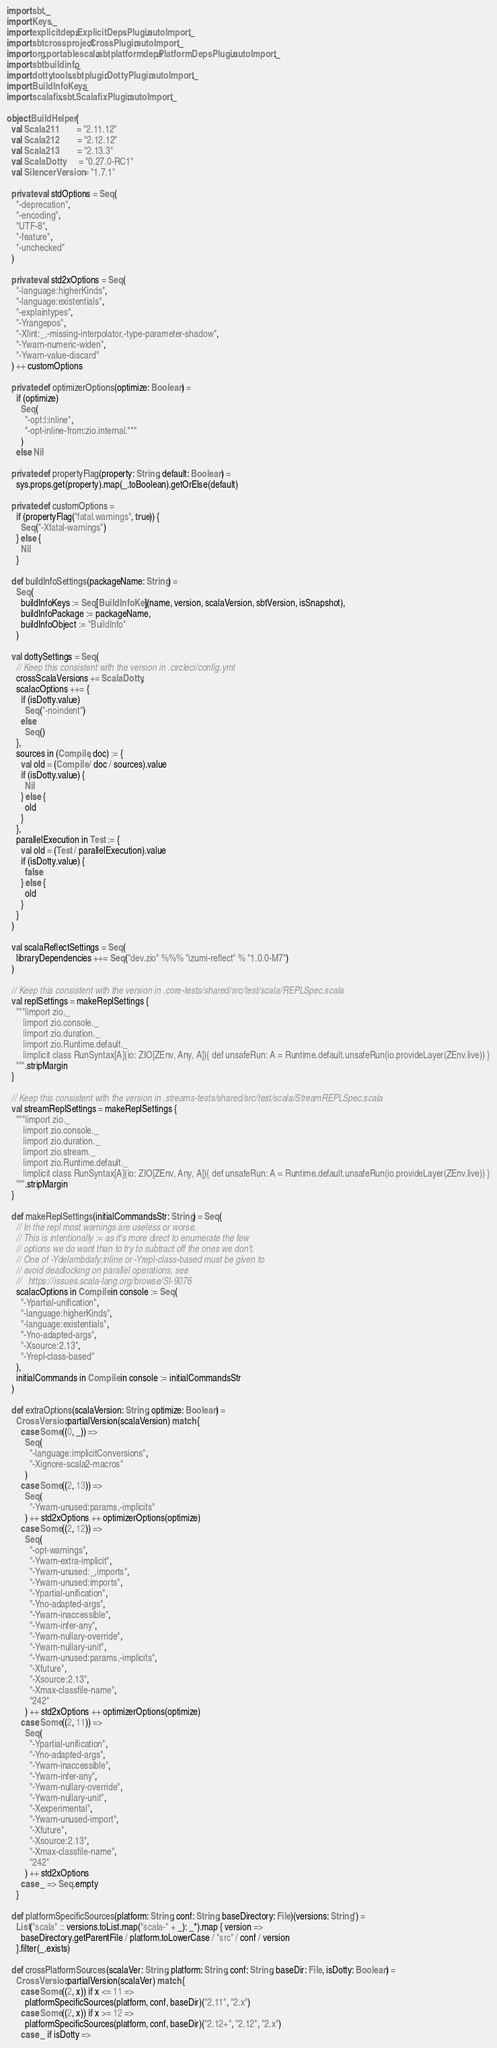<code> <loc_0><loc_0><loc_500><loc_500><_Scala_>import sbt._
import Keys._
import explicitdeps.ExplicitDepsPlugin.autoImport._
import sbtcrossproject.CrossPlugin.autoImport._
import org.portablescala.sbtplatformdeps.PlatformDepsPlugin.autoImport._
import sbtbuildinfo._
import dotty.tools.sbtplugin.DottyPlugin.autoImport._
import BuildInfoKeys._
import scalafix.sbt.ScalafixPlugin.autoImport._

object BuildHelper {
  val Scala211        = "2.11.12"
  val Scala212        = "2.12.12"
  val Scala213        = "2.13.3"
  val ScalaDotty      = "0.27.0-RC1"
  val SilencerVersion = "1.7.1"

  private val stdOptions = Seq(
    "-deprecation",
    "-encoding",
    "UTF-8",
    "-feature",
    "-unchecked"
  )

  private val std2xOptions = Seq(
    "-language:higherKinds",
    "-language:existentials",
    "-explaintypes",
    "-Yrangepos",
    "-Xlint:_,-missing-interpolator,-type-parameter-shadow",
    "-Ywarn-numeric-widen",
    "-Ywarn-value-discard"
  ) ++ customOptions

  private def optimizerOptions(optimize: Boolean) =
    if (optimize)
      Seq(
        "-opt:l:inline",
        "-opt-inline-from:zio.internal.**"
      )
    else Nil

  private def propertyFlag(property: String, default: Boolean) =
    sys.props.get(property).map(_.toBoolean).getOrElse(default)

  private def customOptions =
    if (propertyFlag("fatal.warnings", true)) {
      Seq("-Xfatal-warnings")
    } else {
      Nil
    }

  def buildInfoSettings(packageName: String) =
    Seq(
      buildInfoKeys := Seq[BuildInfoKey](name, version, scalaVersion, sbtVersion, isSnapshot),
      buildInfoPackage := packageName,
      buildInfoObject := "BuildInfo"
    )

  val dottySettings = Seq(
    // Keep this consistent with the version in .circleci/config.yml
    crossScalaVersions += ScalaDotty,
    scalacOptions ++= {
      if (isDotty.value)
        Seq("-noindent")
      else
        Seq()
    },
    sources in (Compile, doc) := {
      val old = (Compile / doc / sources).value
      if (isDotty.value) {
        Nil
      } else {
        old
      }
    },
    parallelExecution in Test := {
      val old = (Test / parallelExecution).value
      if (isDotty.value) {
        false
      } else {
        old
      }
    }
  )

  val scalaReflectSettings = Seq(
    libraryDependencies ++= Seq("dev.zio" %%% "izumi-reflect" % "1.0.0-M7")
  )

  // Keep this consistent with the version in .core-tests/shared/src/test/scala/REPLSpec.scala
  val replSettings = makeReplSettings {
    """|import zio._
       |import zio.console._
       |import zio.duration._
       |import zio.Runtime.default._
       |implicit class RunSyntax[A](io: ZIO[ZEnv, Any, A]){ def unsafeRun: A = Runtime.default.unsafeRun(io.provideLayer(ZEnv.live)) }
    """.stripMargin
  }

  // Keep this consistent with the version in .streams-tests/shared/src/test/scala/StreamREPLSpec.scala
  val streamReplSettings = makeReplSettings {
    """|import zio._
       |import zio.console._
       |import zio.duration._
       |import zio.stream._
       |import zio.Runtime.default._
       |implicit class RunSyntax[A](io: ZIO[ZEnv, Any, A]){ def unsafeRun: A = Runtime.default.unsafeRun(io.provideLayer(ZEnv.live)) }
    """.stripMargin
  }

  def makeReplSettings(initialCommandsStr: String) = Seq(
    // In the repl most warnings are useless or worse.
    // This is intentionally := as it's more direct to enumerate the few
    // options we do want than to try to subtract off the ones we don't.
    // One of -Ydelambdafy:inline or -Yrepl-class-based must be given to
    // avoid deadlocking on parallel operations, see
    //   https://issues.scala-lang.org/browse/SI-9076
    scalacOptions in Compile in console := Seq(
      "-Ypartial-unification",
      "-language:higherKinds",
      "-language:existentials",
      "-Yno-adapted-args",
      "-Xsource:2.13",
      "-Yrepl-class-based"
    ),
    initialCommands in Compile in console := initialCommandsStr
  )

  def extraOptions(scalaVersion: String, optimize: Boolean) =
    CrossVersion.partialVersion(scalaVersion) match {
      case Some((0, _)) =>
        Seq(
          "-language:implicitConversions",
          "-Xignore-scala2-macros"
        )
      case Some((2, 13)) =>
        Seq(
          "-Ywarn-unused:params,-implicits"
        ) ++ std2xOptions ++ optimizerOptions(optimize)
      case Some((2, 12)) =>
        Seq(
          "-opt-warnings",
          "-Ywarn-extra-implicit",
          "-Ywarn-unused:_,imports",
          "-Ywarn-unused:imports",
          "-Ypartial-unification",
          "-Yno-adapted-args",
          "-Ywarn-inaccessible",
          "-Ywarn-infer-any",
          "-Ywarn-nullary-override",
          "-Ywarn-nullary-unit",
          "-Ywarn-unused:params,-implicits",
          "-Xfuture",
          "-Xsource:2.13",
          "-Xmax-classfile-name",
          "242"
        ) ++ std2xOptions ++ optimizerOptions(optimize)
      case Some((2, 11)) =>
        Seq(
          "-Ypartial-unification",
          "-Yno-adapted-args",
          "-Ywarn-inaccessible",
          "-Ywarn-infer-any",
          "-Ywarn-nullary-override",
          "-Ywarn-nullary-unit",
          "-Xexperimental",
          "-Ywarn-unused-import",
          "-Xfuture",
          "-Xsource:2.13",
          "-Xmax-classfile-name",
          "242"
        ) ++ std2xOptions
      case _ => Seq.empty
    }

  def platformSpecificSources(platform: String, conf: String, baseDirectory: File)(versions: String*) =
    List("scala" :: versions.toList.map("scala-" + _): _*).map { version =>
      baseDirectory.getParentFile / platform.toLowerCase / "src" / conf / version
    }.filter(_.exists)

  def crossPlatformSources(scalaVer: String, platform: String, conf: String, baseDir: File, isDotty: Boolean) =
    CrossVersion.partialVersion(scalaVer) match {
      case Some((2, x)) if x <= 11 =>
        platformSpecificSources(platform, conf, baseDir)("2.11", "2.x")
      case Some((2, x)) if x >= 12 =>
        platformSpecificSources(platform, conf, baseDir)("2.12+", "2.12", "2.x")
      case _ if isDotty =></code> 